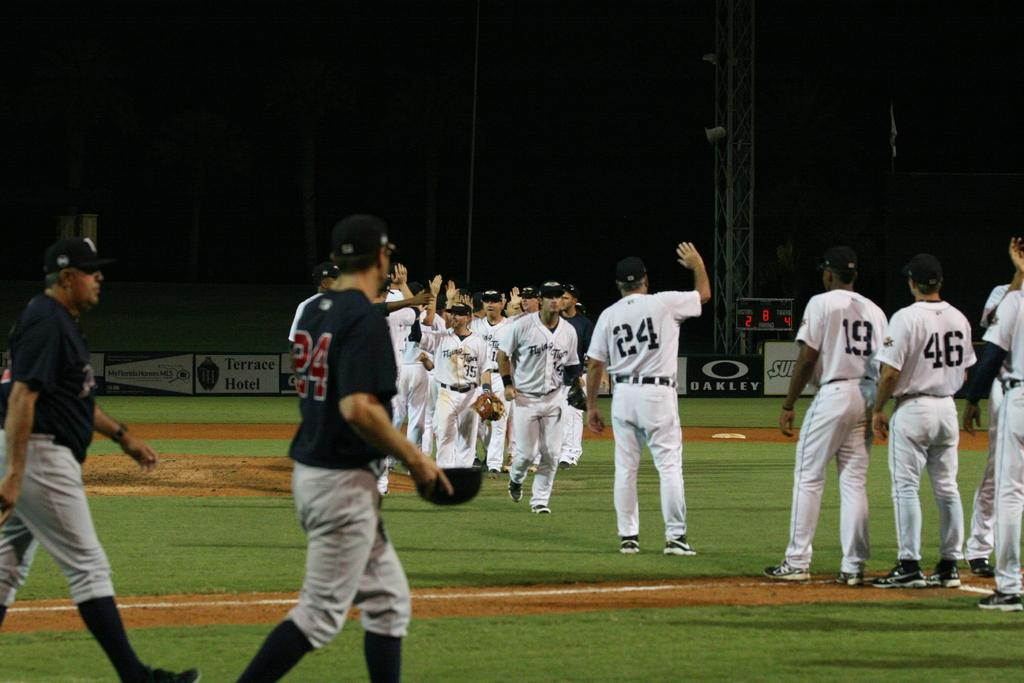<image>
Give a short and clear explanation of the subsequent image. Player number 24 is waving at someone across the field. 